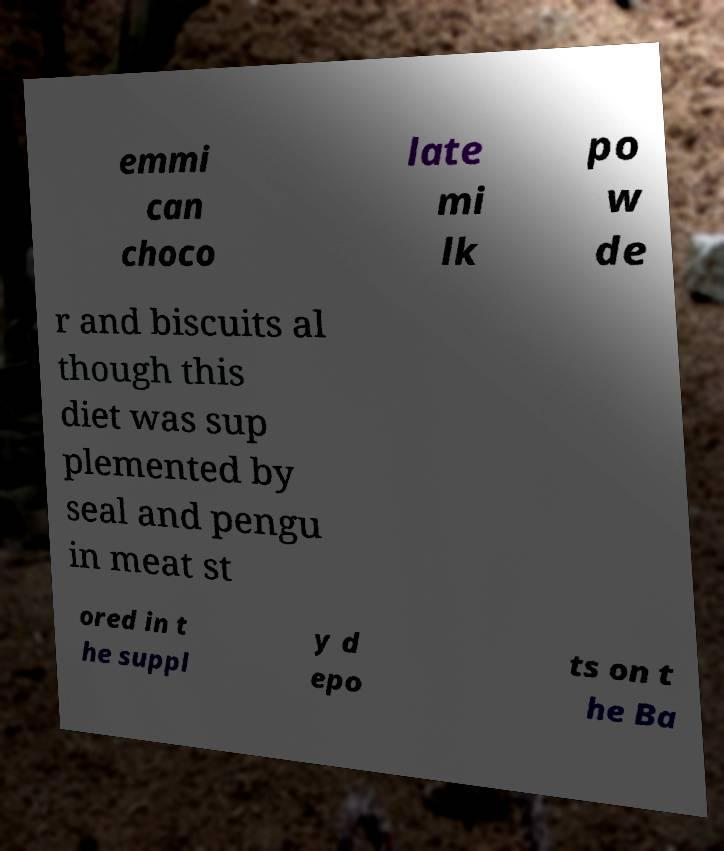I need the written content from this picture converted into text. Can you do that? emmi can choco late mi lk po w de r and biscuits al though this diet was sup plemented by seal and pengu in meat st ored in t he suppl y d epo ts on t he Ba 